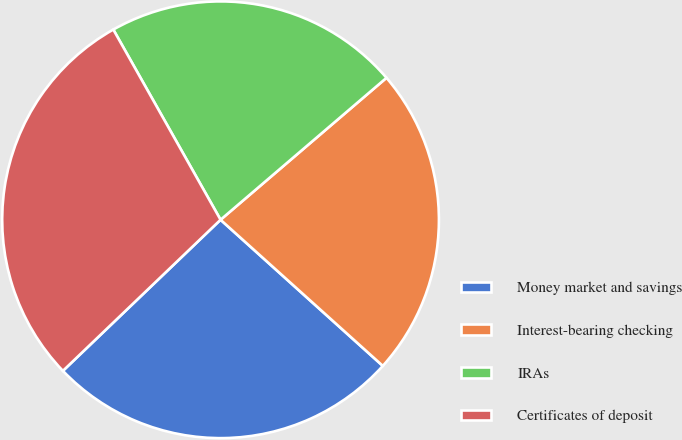Convert chart to OTSL. <chart><loc_0><loc_0><loc_500><loc_500><pie_chart><fcel>Money market and savings<fcel>Interest-bearing checking<fcel>IRAs<fcel>Certificates of deposit<nl><fcel>26.17%<fcel>22.93%<fcel>21.91%<fcel>28.99%<nl></chart> 